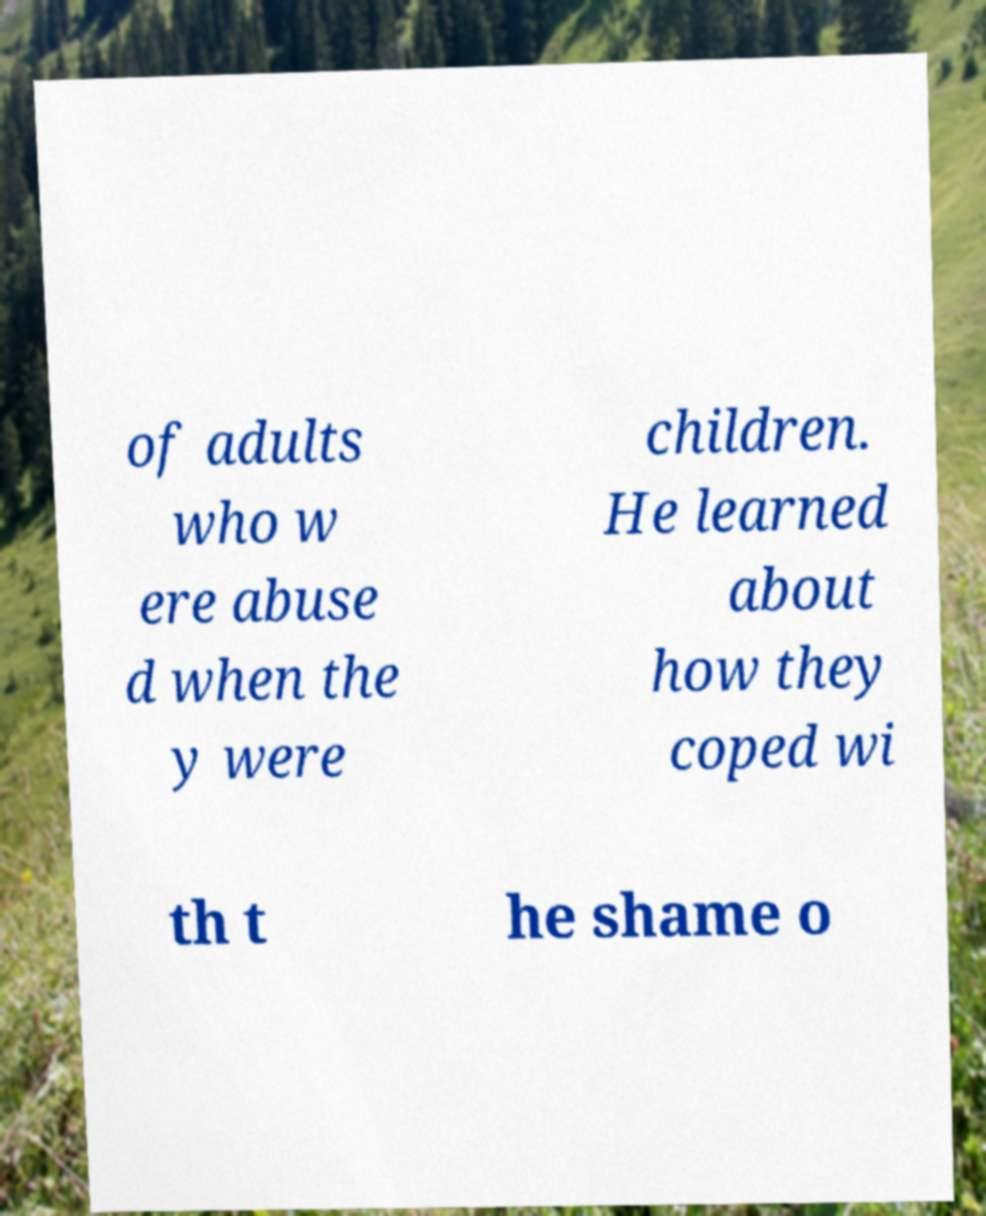Can you read and provide the text displayed in the image?This photo seems to have some interesting text. Can you extract and type it out for me? of adults who w ere abuse d when the y were children. He learned about how they coped wi th t he shame o 